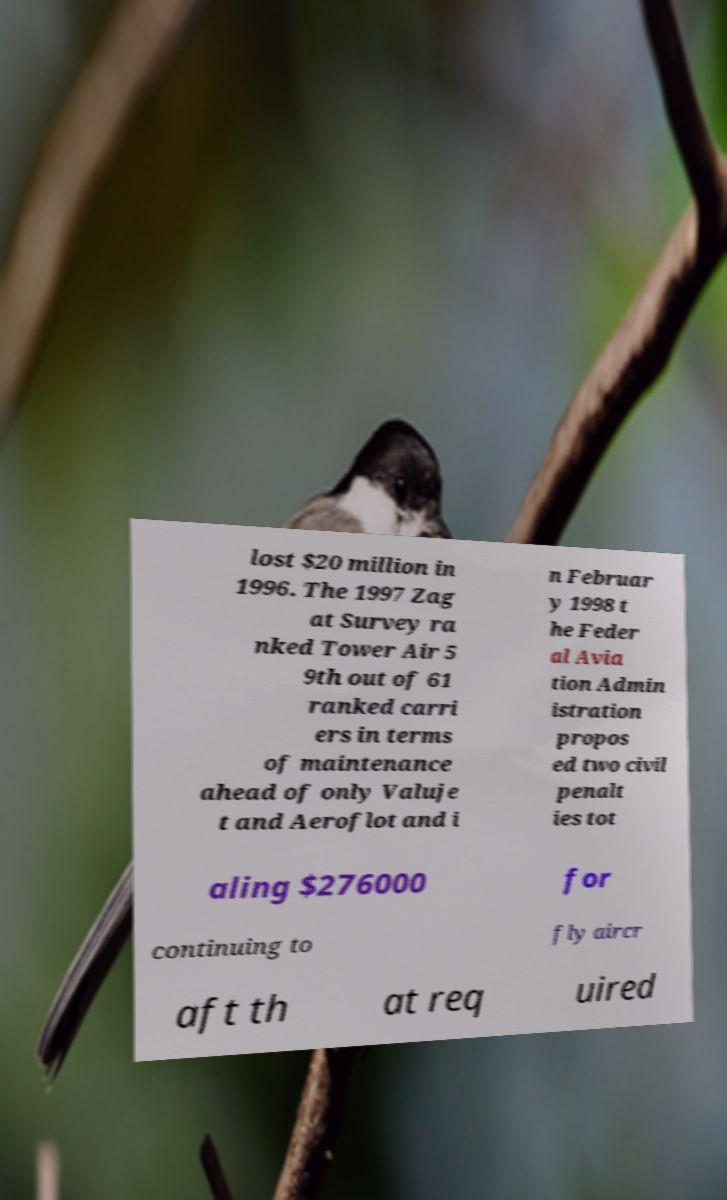Can you accurately transcribe the text from the provided image for me? lost $20 million in 1996. The 1997 Zag at Survey ra nked Tower Air 5 9th out of 61 ranked carri ers in terms of maintenance ahead of only Valuje t and Aeroflot and i n Februar y 1998 t he Feder al Avia tion Admin istration propos ed two civil penalt ies tot aling $276000 for continuing to fly aircr aft th at req uired 